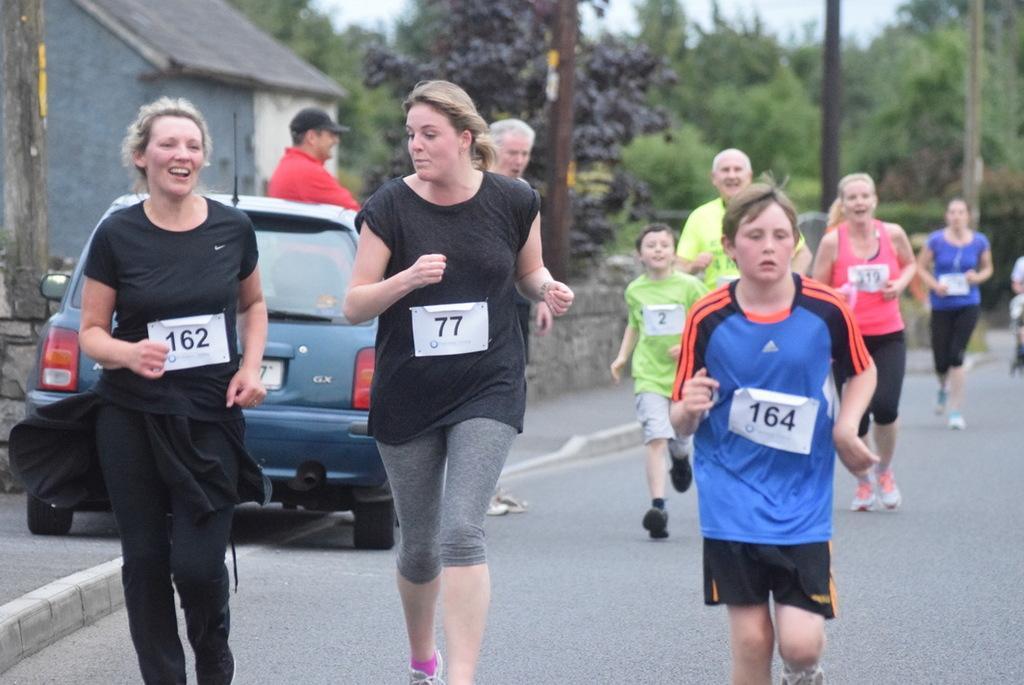In one or two sentences, can you explain what this image depicts? In this picture we can see a group of people running on the road, car, house, trees, poles and in the background we can see the sky. 